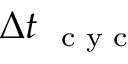<formula> <loc_0><loc_0><loc_500><loc_500>\Delta t _ { c y c }</formula> 